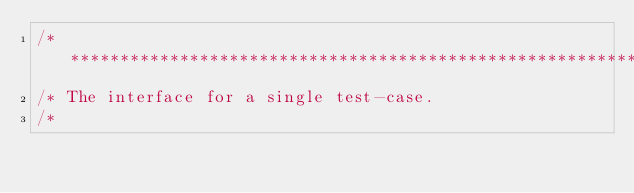<code> <loc_0><loc_0><loc_500><loc_500><_Java_>/**************************************************************************
/* The interface for a single test-case.
/*</code> 